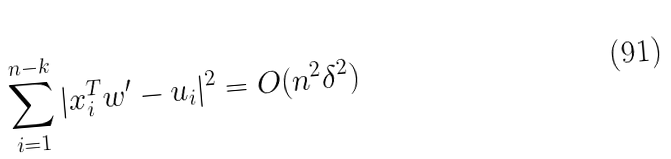Convert formula to latex. <formula><loc_0><loc_0><loc_500><loc_500>\sum _ { i = 1 } ^ { n - k } | x _ { i } ^ { T } w ^ { \prime } - u _ { i } | ^ { 2 } = O ( n ^ { 2 } \delta ^ { 2 } )</formula> 